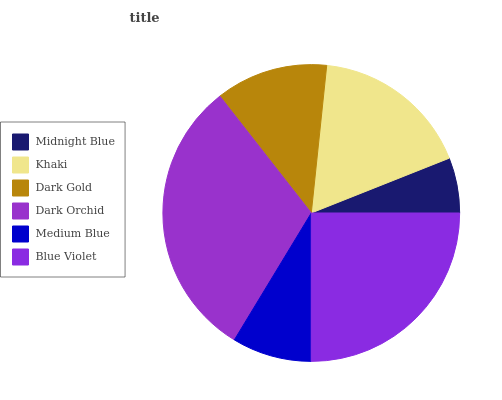Is Midnight Blue the minimum?
Answer yes or no. Yes. Is Dark Orchid the maximum?
Answer yes or no. Yes. Is Khaki the minimum?
Answer yes or no. No. Is Khaki the maximum?
Answer yes or no. No. Is Khaki greater than Midnight Blue?
Answer yes or no. Yes. Is Midnight Blue less than Khaki?
Answer yes or no. Yes. Is Midnight Blue greater than Khaki?
Answer yes or no. No. Is Khaki less than Midnight Blue?
Answer yes or no. No. Is Khaki the high median?
Answer yes or no. Yes. Is Dark Gold the low median?
Answer yes or no. Yes. Is Blue Violet the high median?
Answer yes or no. No. Is Blue Violet the low median?
Answer yes or no. No. 